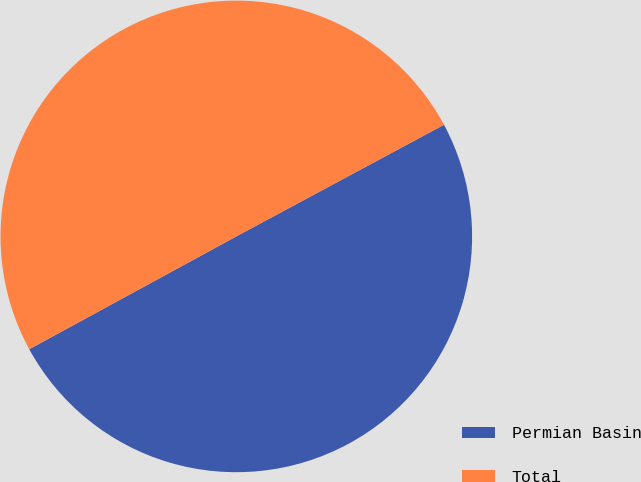<chart> <loc_0><loc_0><loc_500><loc_500><pie_chart><fcel>Permian Basin<fcel>Total<nl><fcel>49.91%<fcel>50.09%<nl></chart> 